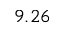Convert formula to latex. <formula><loc_0><loc_0><loc_500><loc_500>9 . 2 6</formula> 